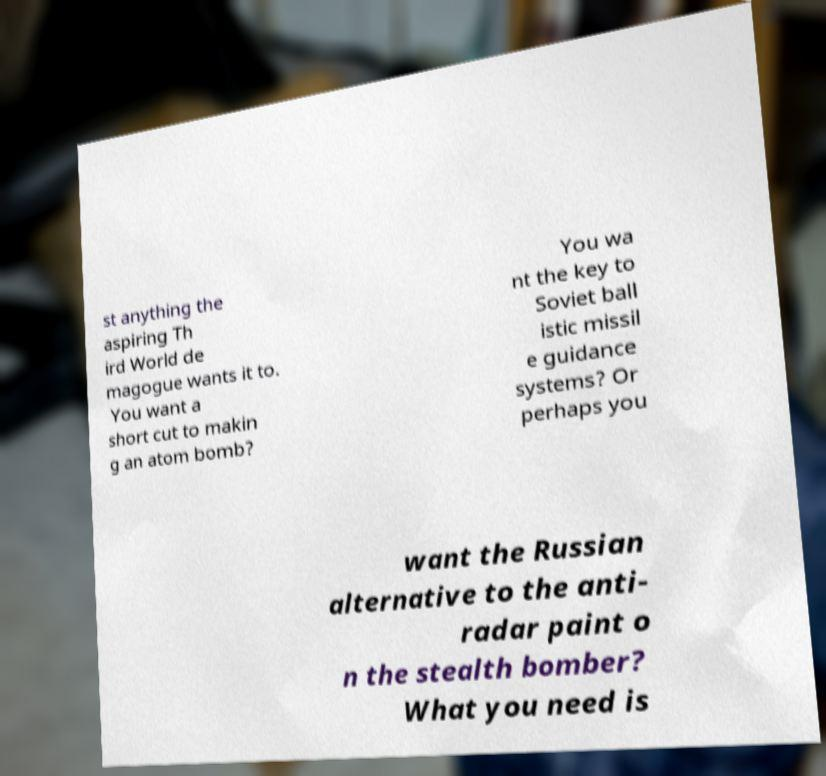Can you accurately transcribe the text from the provided image for me? st anything the aspiring Th ird World de magogue wants it to. You want a short cut to makin g an atom bomb? You wa nt the key to Soviet ball istic missil e guidance systems? Or perhaps you want the Russian alternative to the anti- radar paint o n the stealth bomber? What you need is 